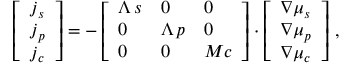<formula> <loc_0><loc_0><loc_500><loc_500>\left [ \begin{array} { l } { j _ { s } } \\ { j _ { p } } \\ { j _ { c } } \end{array} \right ] = - \left [ \begin{array} { l l l } { \Lambda \, s } & { 0 } & { 0 } \\ { 0 } & { \Lambda \, p } & { 0 } \\ { 0 } & { 0 } & { M c } \end{array} \right ] \cdot \left [ \begin{array} { l } { \boldsymbol \nabla \mu _ { s } } \\ { \boldsymbol \nabla \mu _ { p } } \\ { \boldsymbol \nabla \mu _ { c } } \end{array} \right ] \, ,</formula> 